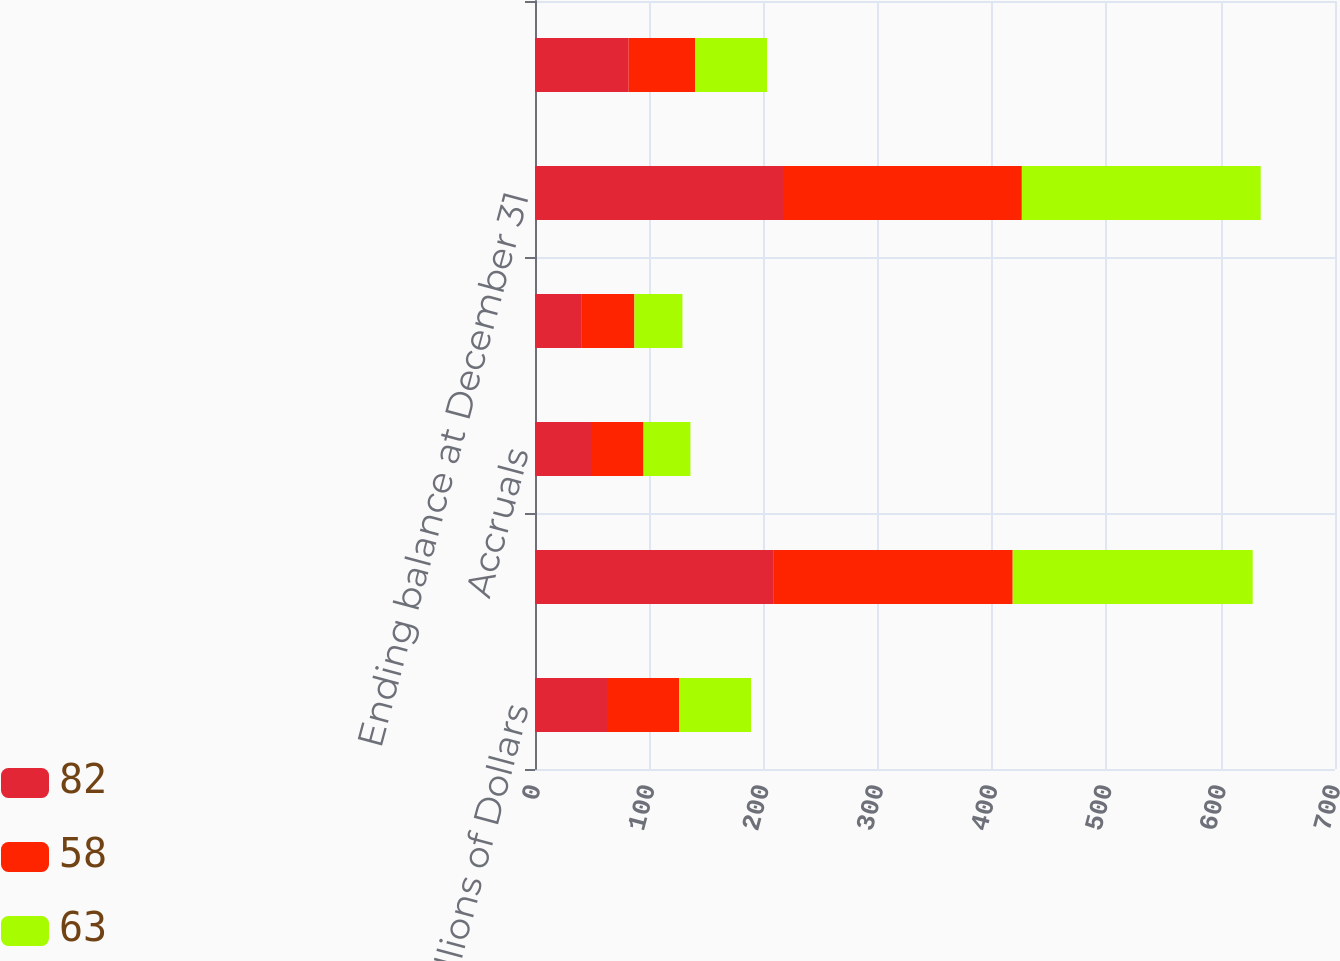Convert chart. <chart><loc_0><loc_0><loc_500><loc_500><stacked_bar_chart><ecel><fcel>Millions of Dollars<fcel>Beginning balance<fcel>Accruals<fcel>Payments<fcel>Ending balance at December 31<fcel>Current portion ending balance<nl><fcel>82<fcel>63<fcel>209<fcel>49<fcel>41<fcel>217<fcel>82<nl><fcel>58<fcel>63<fcel>209<fcel>46<fcel>46<fcel>209<fcel>58<nl><fcel>63<fcel>63<fcel>210<fcel>41<fcel>42<fcel>209<fcel>63<nl></chart> 